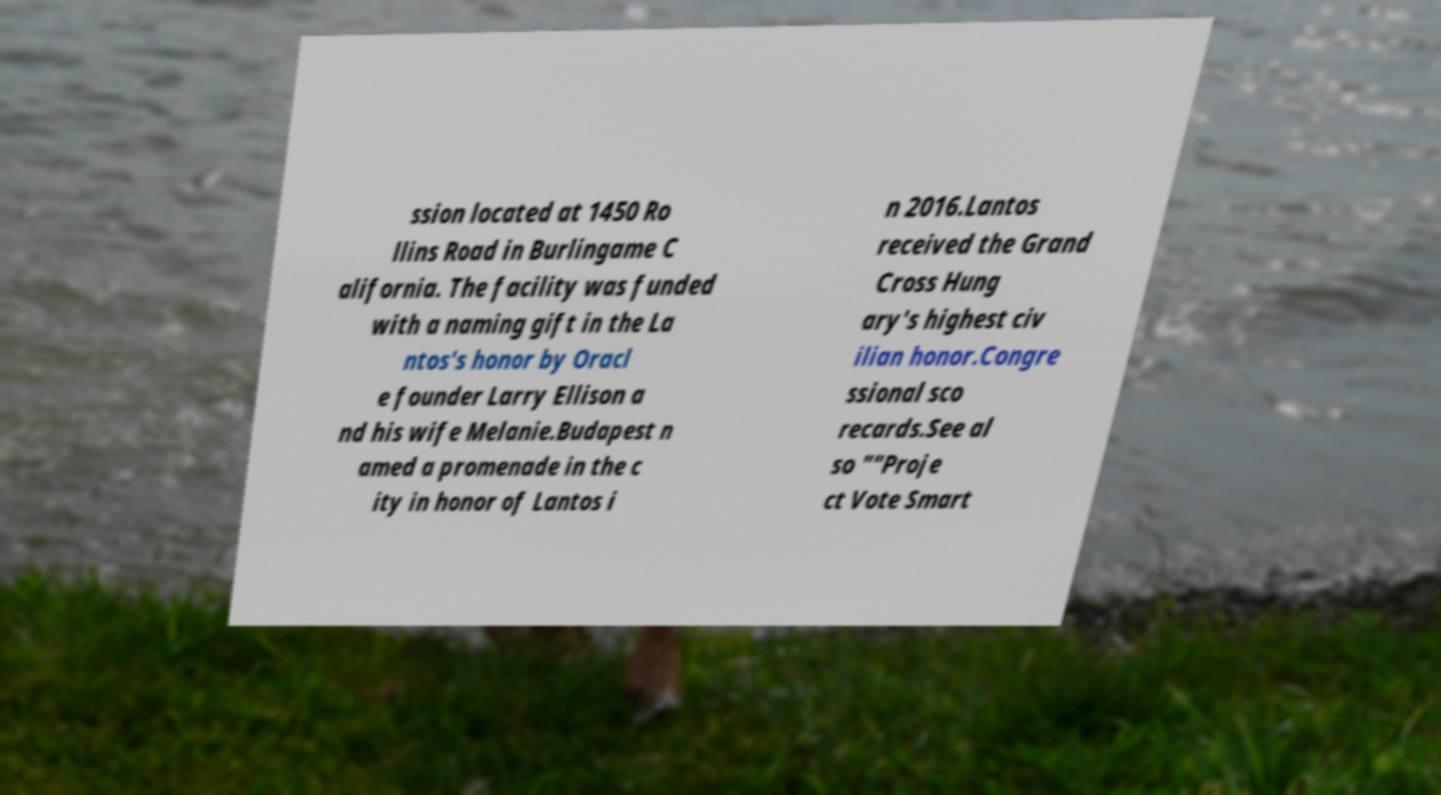Can you read and provide the text displayed in the image?This photo seems to have some interesting text. Can you extract and type it out for me? ssion located at 1450 Ro llins Road in Burlingame C alifornia. The facility was funded with a naming gift in the La ntos's honor by Oracl e founder Larry Ellison a nd his wife Melanie.Budapest n amed a promenade in the c ity in honor of Lantos i n 2016.Lantos received the Grand Cross Hung ary's highest civ ilian honor.Congre ssional sco recards.See al so ""Proje ct Vote Smart 